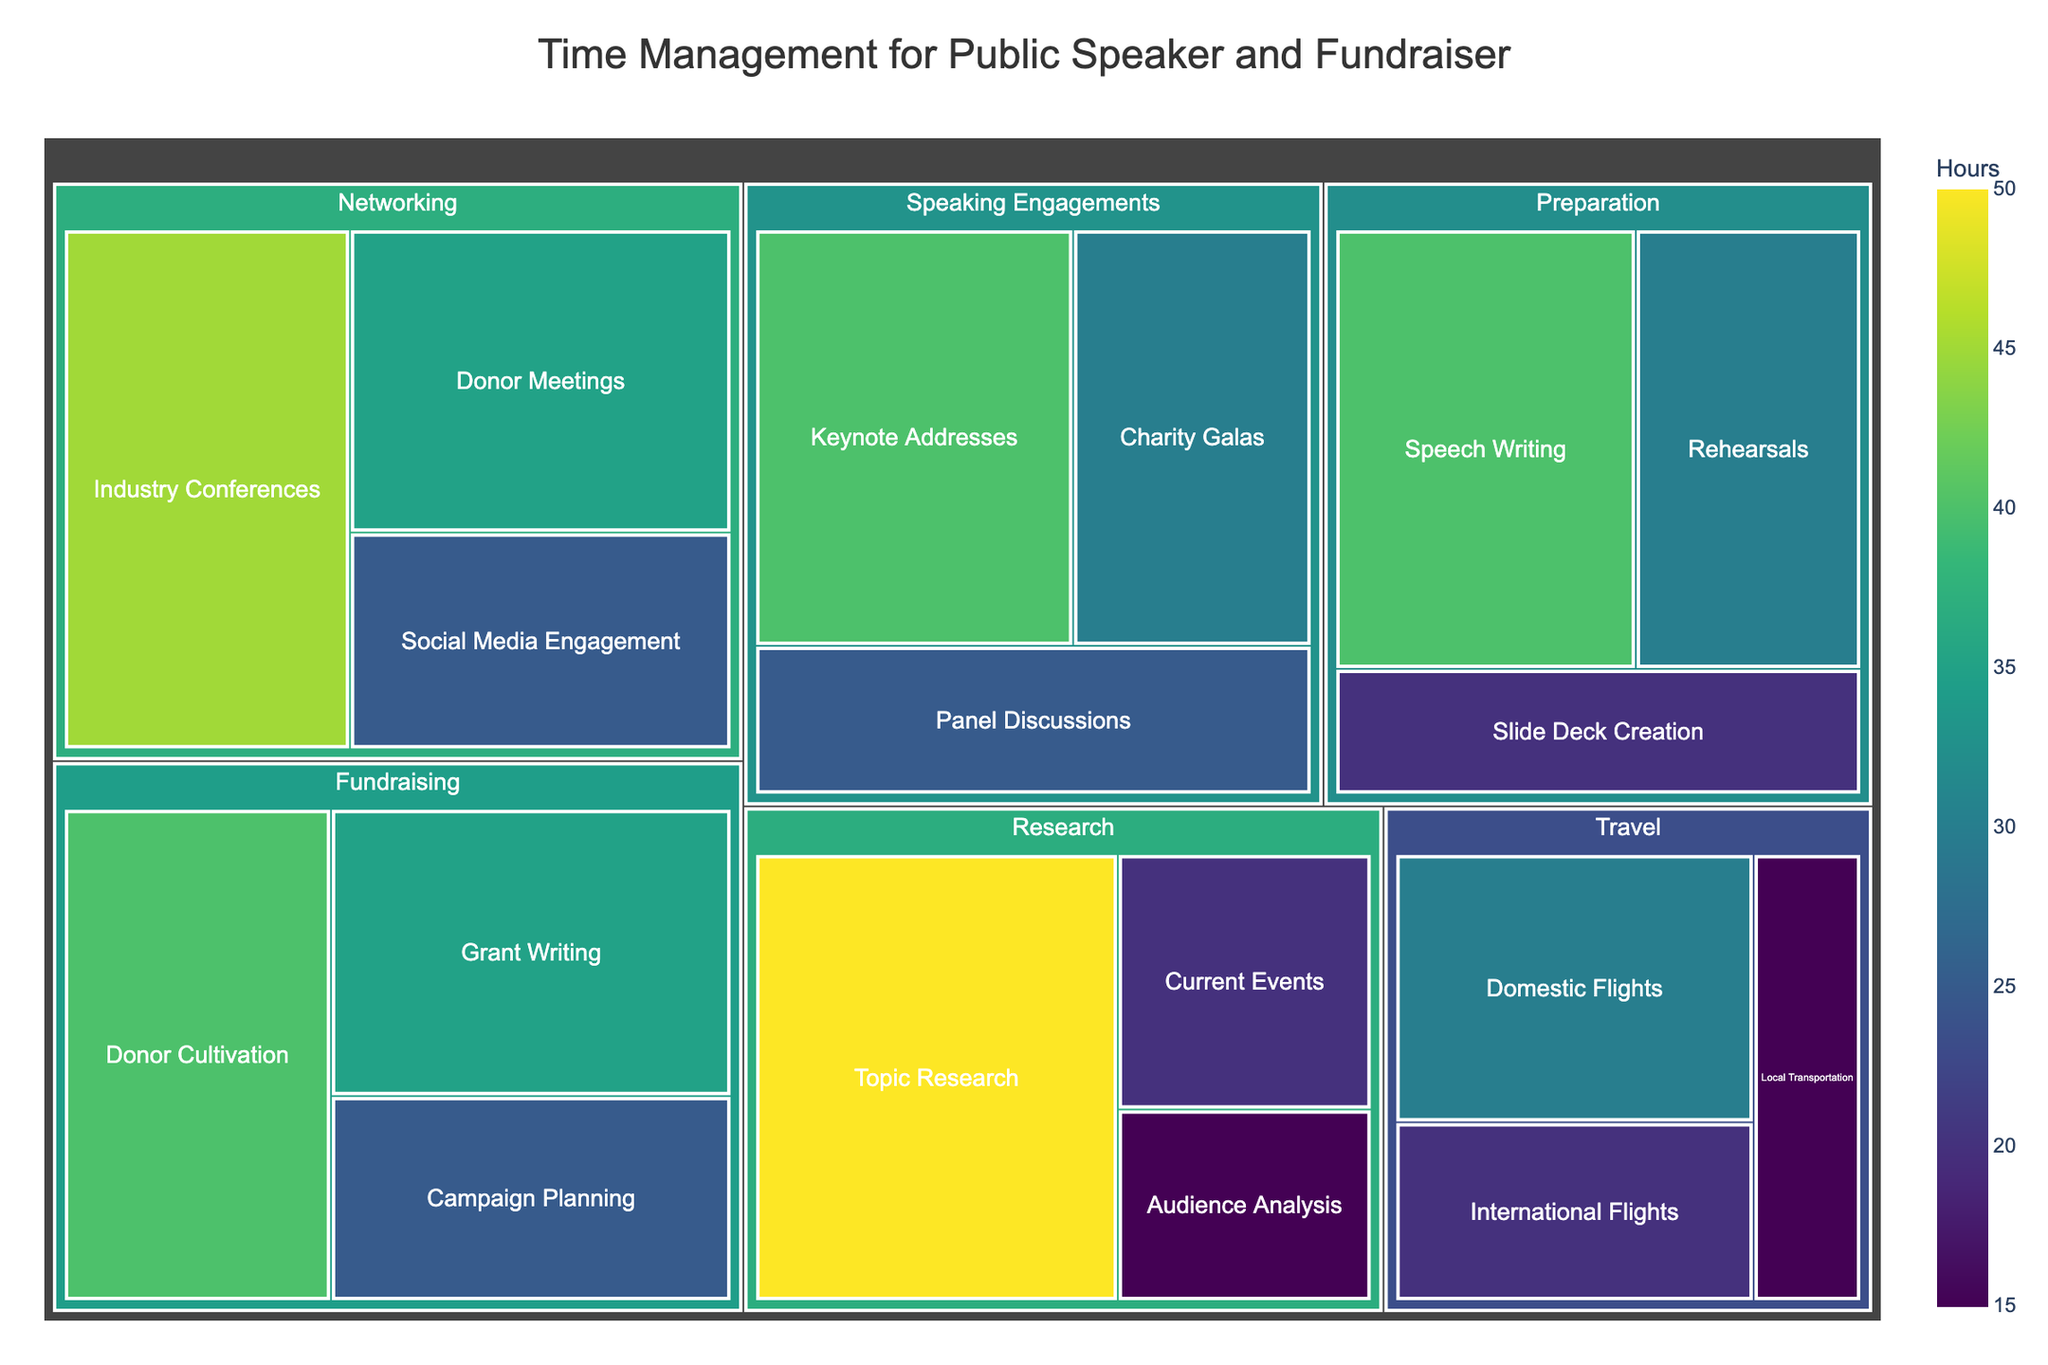What activity takes the most amount of time according to the treemap? The largest tile represents the activity taking the most time. The size corresponds to the 'Hours' value.
Answer: Topic Research How many hours are spent on donor cultivation within the Fundraising category? Locate the 'Fundraising' category and find the 'Donor Cultivation' subcategory within it. The number of hours is displayed inside the tile.
Answer: 40 Which category, Networking or Preparation, has more total hours? Sum the hours for all subcategories within each category and compare the totals: Networking (35+45+25=105), Preparation (40+20+30=90).
Answer: Networking What is the average number of hours spent on activities within the Travel category? Sum the hours of all the Travel subcategories and divide by the number of subcategories: (30+20+15)/3.
Answer: 21.67 Which subcategory within Speaking Engagements has the least amount of time allocated? Locate the 'Speaking Engagements' category and compare the 'Hours' values of its subcategories.
Answer: Panel Discussions What is the total number of hours spent on Speaking Engagements and Fundraising combined? Sum the hours of all subcategories within both categories: (40+25+30) + (35+40+25).
Answer: 195 Is more time spent on Travel or Networking activities? Compare the total hours for all subcategories within each category: Travel (30+20+15) vs. Networking (35+45+25).
Answer: Networking Which activity in the Research category requires the least time? Identify the 'Research' category and examine the 'Hours' for its subcategories.
Answer: Audience Analysis 